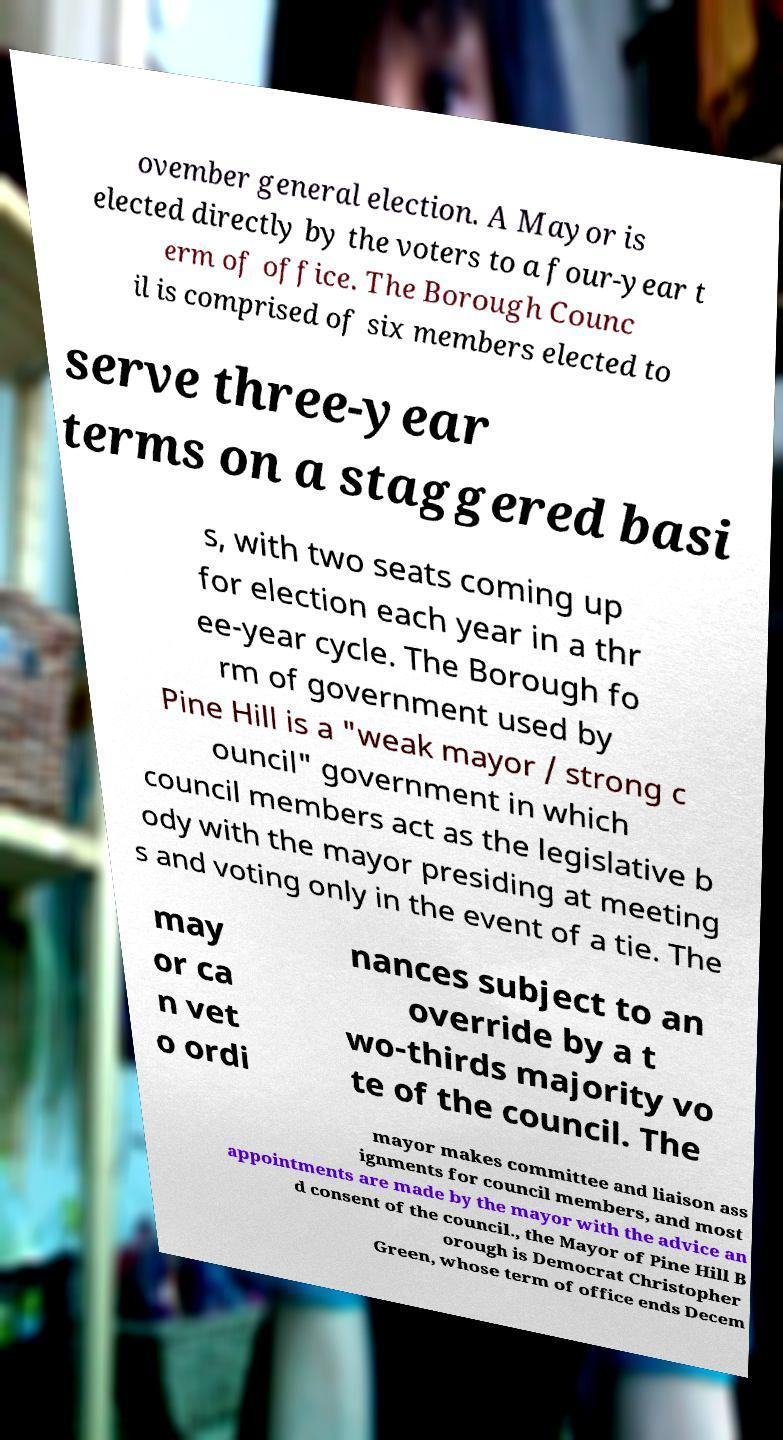There's text embedded in this image that I need extracted. Can you transcribe it verbatim? ovember general election. A Mayor is elected directly by the voters to a four-year t erm of office. The Borough Counc il is comprised of six members elected to serve three-year terms on a staggered basi s, with two seats coming up for election each year in a thr ee-year cycle. The Borough fo rm of government used by Pine Hill is a "weak mayor / strong c ouncil" government in which council members act as the legislative b ody with the mayor presiding at meeting s and voting only in the event of a tie. The may or ca n vet o ordi nances subject to an override by a t wo-thirds majority vo te of the council. The mayor makes committee and liaison ass ignments for council members, and most appointments are made by the mayor with the advice an d consent of the council., the Mayor of Pine Hill B orough is Democrat Christopher Green, whose term of office ends Decem 